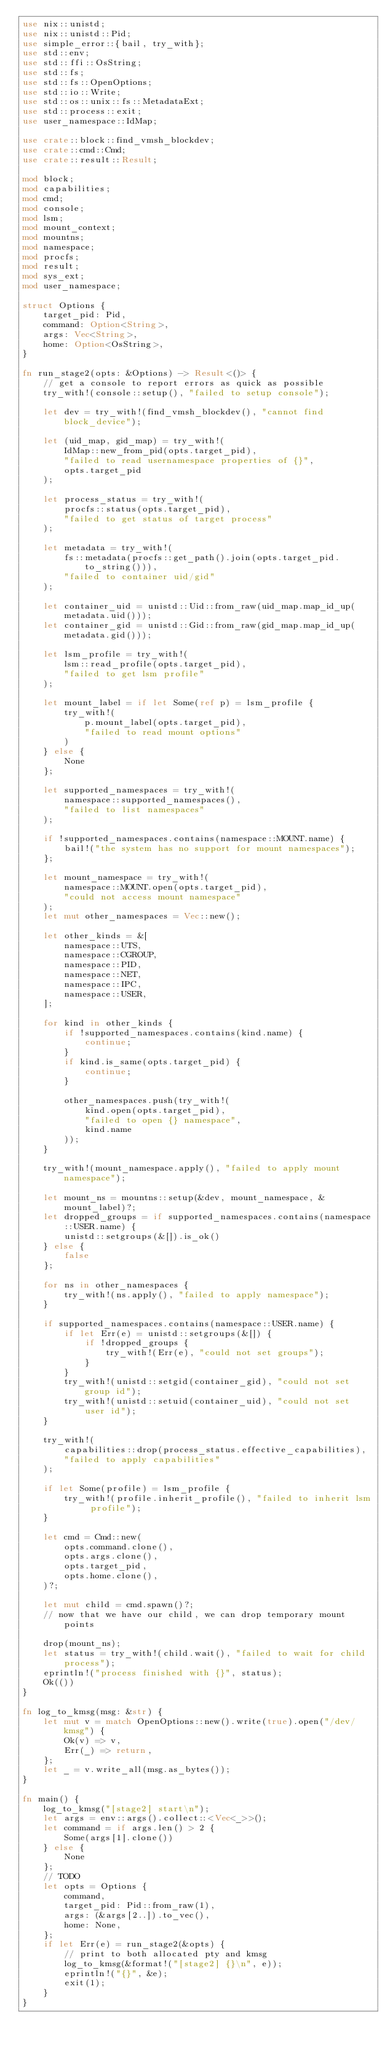Convert code to text. <code><loc_0><loc_0><loc_500><loc_500><_Rust_>use nix::unistd;
use nix::unistd::Pid;
use simple_error::{bail, try_with};
use std::env;
use std::ffi::OsString;
use std::fs;
use std::fs::OpenOptions;
use std::io::Write;
use std::os::unix::fs::MetadataExt;
use std::process::exit;
use user_namespace::IdMap;

use crate::block::find_vmsh_blockdev;
use crate::cmd::Cmd;
use crate::result::Result;

mod block;
mod capabilities;
mod cmd;
mod console;
mod lsm;
mod mount_context;
mod mountns;
mod namespace;
mod procfs;
mod result;
mod sys_ext;
mod user_namespace;

struct Options {
    target_pid: Pid,
    command: Option<String>,
    args: Vec<String>,
    home: Option<OsString>,
}

fn run_stage2(opts: &Options) -> Result<()> {
    // get a console to report errors as quick as possible
    try_with!(console::setup(), "failed to setup console");

    let dev = try_with!(find_vmsh_blockdev(), "cannot find block_device");

    let (uid_map, gid_map) = try_with!(
        IdMap::new_from_pid(opts.target_pid),
        "failed to read usernamespace properties of {}",
        opts.target_pid
    );

    let process_status = try_with!(
        procfs::status(opts.target_pid),
        "failed to get status of target process"
    );

    let metadata = try_with!(
        fs::metadata(procfs::get_path().join(opts.target_pid.to_string())),
        "failed to container uid/gid"
    );

    let container_uid = unistd::Uid::from_raw(uid_map.map_id_up(metadata.uid()));
    let container_gid = unistd::Gid::from_raw(gid_map.map_id_up(metadata.gid()));

    let lsm_profile = try_with!(
        lsm::read_profile(opts.target_pid),
        "failed to get lsm profile"
    );

    let mount_label = if let Some(ref p) = lsm_profile {
        try_with!(
            p.mount_label(opts.target_pid),
            "failed to read mount options"
        )
    } else {
        None
    };

    let supported_namespaces = try_with!(
        namespace::supported_namespaces(),
        "failed to list namespaces"
    );

    if !supported_namespaces.contains(namespace::MOUNT.name) {
        bail!("the system has no support for mount namespaces");
    };

    let mount_namespace = try_with!(
        namespace::MOUNT.open(opts.target_pid),
        "could not access mount namespace"
    );
    let mut other_namespaces = Vec::new();

    let other_kinds = &[
        namespace::UTS,
        namespace::CGROUP,
        namespace::PID,
        namespace::NET,
        namespace::IPC,
        namespace::USER,
    ];

    for kind in other_kinds {
        if !supported_namespaces.contains(kind.name) {
            continue;
        }
        if kind.is_same(opts.target_pid) {
            continue;
        }

        other_namespaces.push(try_with!(
            kind.open(opts.target_pid),
            "failed to open {} namespace",
            kind.name
        ));
    }

    try_with!(mount_namespace.apply(), "failed to apply mount namespace");

    let mount_ns = mountns::setup(&dev, mount_namespace, &mount_label)?;
    let dropped_groups = if supported_namespaces.contains(namespace::USER.name) {
        unistd::setgroups(&[]).is_ok()
    } else {
        false
    };

    for ns in other_namespaces {
        try_with!(ns.apply(), "failed to apply namespace");
    }

    if supported_namespaces.contains(namespace::USER.name) {
        if let Err(e) = unistd::setgroups(&[]) {
            if !dropped_groups {
                try_with!(Err(e), "could not set groups");
            }
        }
        try_with!(unistd::setgid(container_gid), "could not set group id");
        try_with!(unistd::setuid(container_uid), "could not set user id");
    }

    try_with!(
        capabilities::drop(process_status.effective_capabilities),
        "failed to apply capabilities"
    );

    if let Some(profile) = lsm_profile {
        try_with!(profile.inherit_profile(), "failed to inherit lsm profile");
    }

    let cmd = Cmd::new(
        opts.command.clone(),
        opts.args.clone(),
        opts.target_pid,
        opts.home.clone(),
    )?;

    let mut child = cmd.spawn()?;
    // now that we have our child, we can drop temporary mount points

    drop(mount_ns);
    let status = try_with!(child.wait(), "failed to wait for child process");
    eprintln!("process finished with {}", status);
    Ok(())
}

fn log_to_kmsg(msg: &str) {
    let mut v = match OpenOptions::new().write(true).open("/dev/kmsg") {
        Ok(v) => v,
        Err(_) => return,
    };
    let _ = v.write_all(msg.as_bytes());
}

fn main() {
    log_to_kmsg("[stage2] start\n");
    let args = env::args().collect::<Vec<_>>();
    let command = if args.len() > 2 {
        Some(args[1].clone())
    } else {
        None
    };
    // TODO
    let opts = Options {
        command,
        target_pid: Pid::from_raw(1),
        args: (&args[2..]).to_vec(),
        home: None,
    };
    if let Err(e) = run_stage2(&opts) {
        // print to both allocated pty and kmsg
        log_to_kmsg(&format!("[stage2] {}\n", e));
        eprintln!("{}", &e);
        exit(1);
    }
}
</code> 